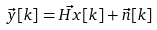Convert formula to latex. <formula><loc_0><loc_0><loc_500><loc_500>\vec { y } [ k ] = \vec { H x } [ k ] + \vec { n } [ k ]</formula> 